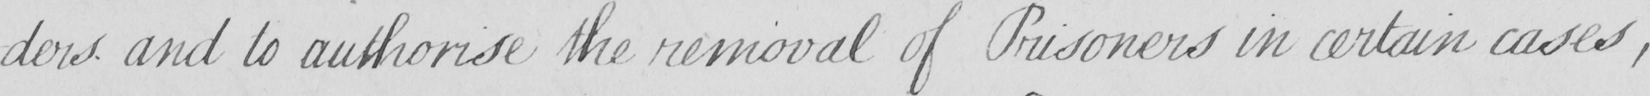What text is written in this handwritten line? -ders and to authorise the removal of Prisoners in certain cases , 